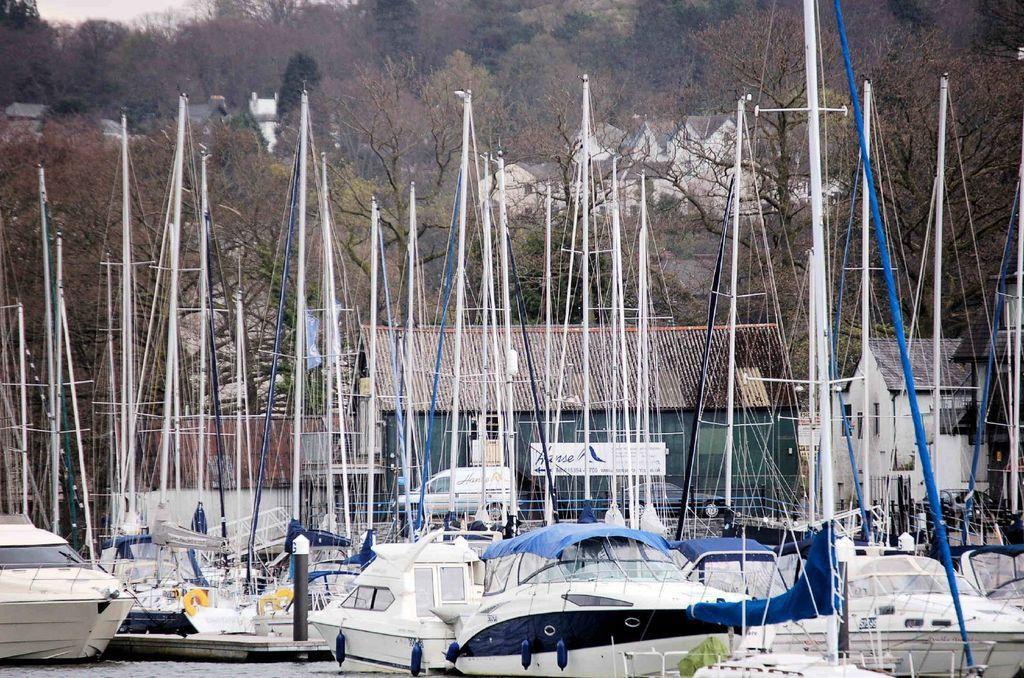Can you describe this image briefly? In the picture we can see some boats in the water, which are white in color and blue in some part with a pole on it and in the background, we can see some house and trees and in the background also we can see some trees and some houses and some part of the sky. 